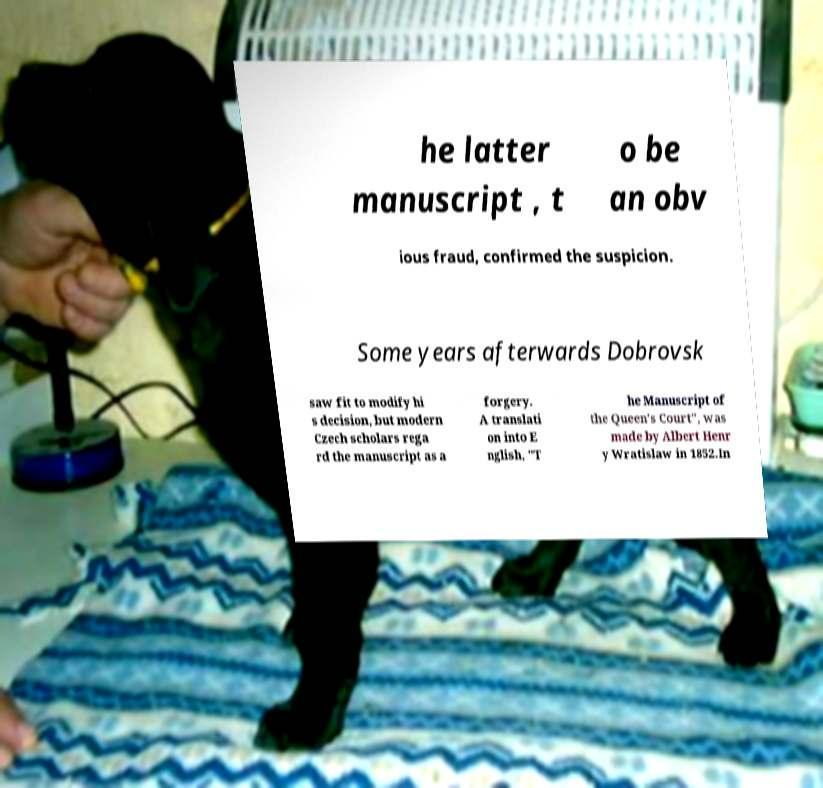I need the written content from this picture converted into text. Can you do that? he latter manuscript , t o be an obv ious fraud, confirmed the suspicion. Some years afterwards Dobrovsk saw fit to modify hi s decision, but modern Czech scholars rega rd the manuscript as a forgery. A translati on into E nglish, "T he Manuscript of the Queen's Court", was made by Albert Henr y Wratislaw in 1852.In 